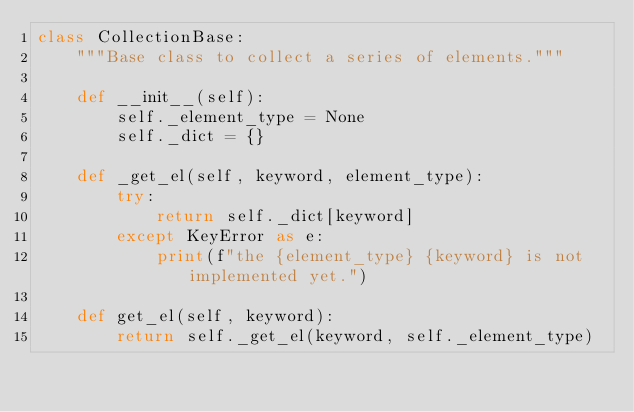Convert code to text. <code><loc_0><loc_0><loc_500><loc_500><_Python_>class CollectionBase:
    """Base class to collect a series of elements."""

    def __init__(self):
        self._element_type = None
        self._dict = {}

    def _get_el(self, keyword, element_type):
        try:
            return self._dict[keyword]
        except KeyError as e:
            print(f"the {element_type} {keyword} is not implemented yet.")

    def get_el(self, keyword):
        return self._get_el(keyword, self._element_type)
</code> 